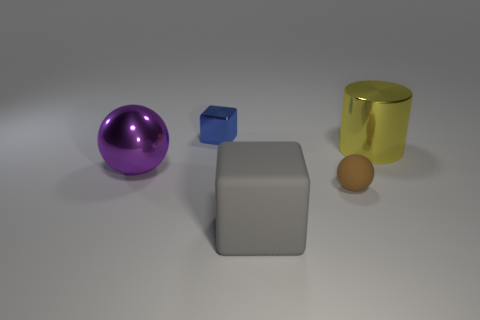Can you describe the lighting in the scene? The scene has soft, diffused lighting that casts gentle shadows on the surface. There doesn't appear to be a single, harsh light source, but rather a more ambient light illuminating the objects. 